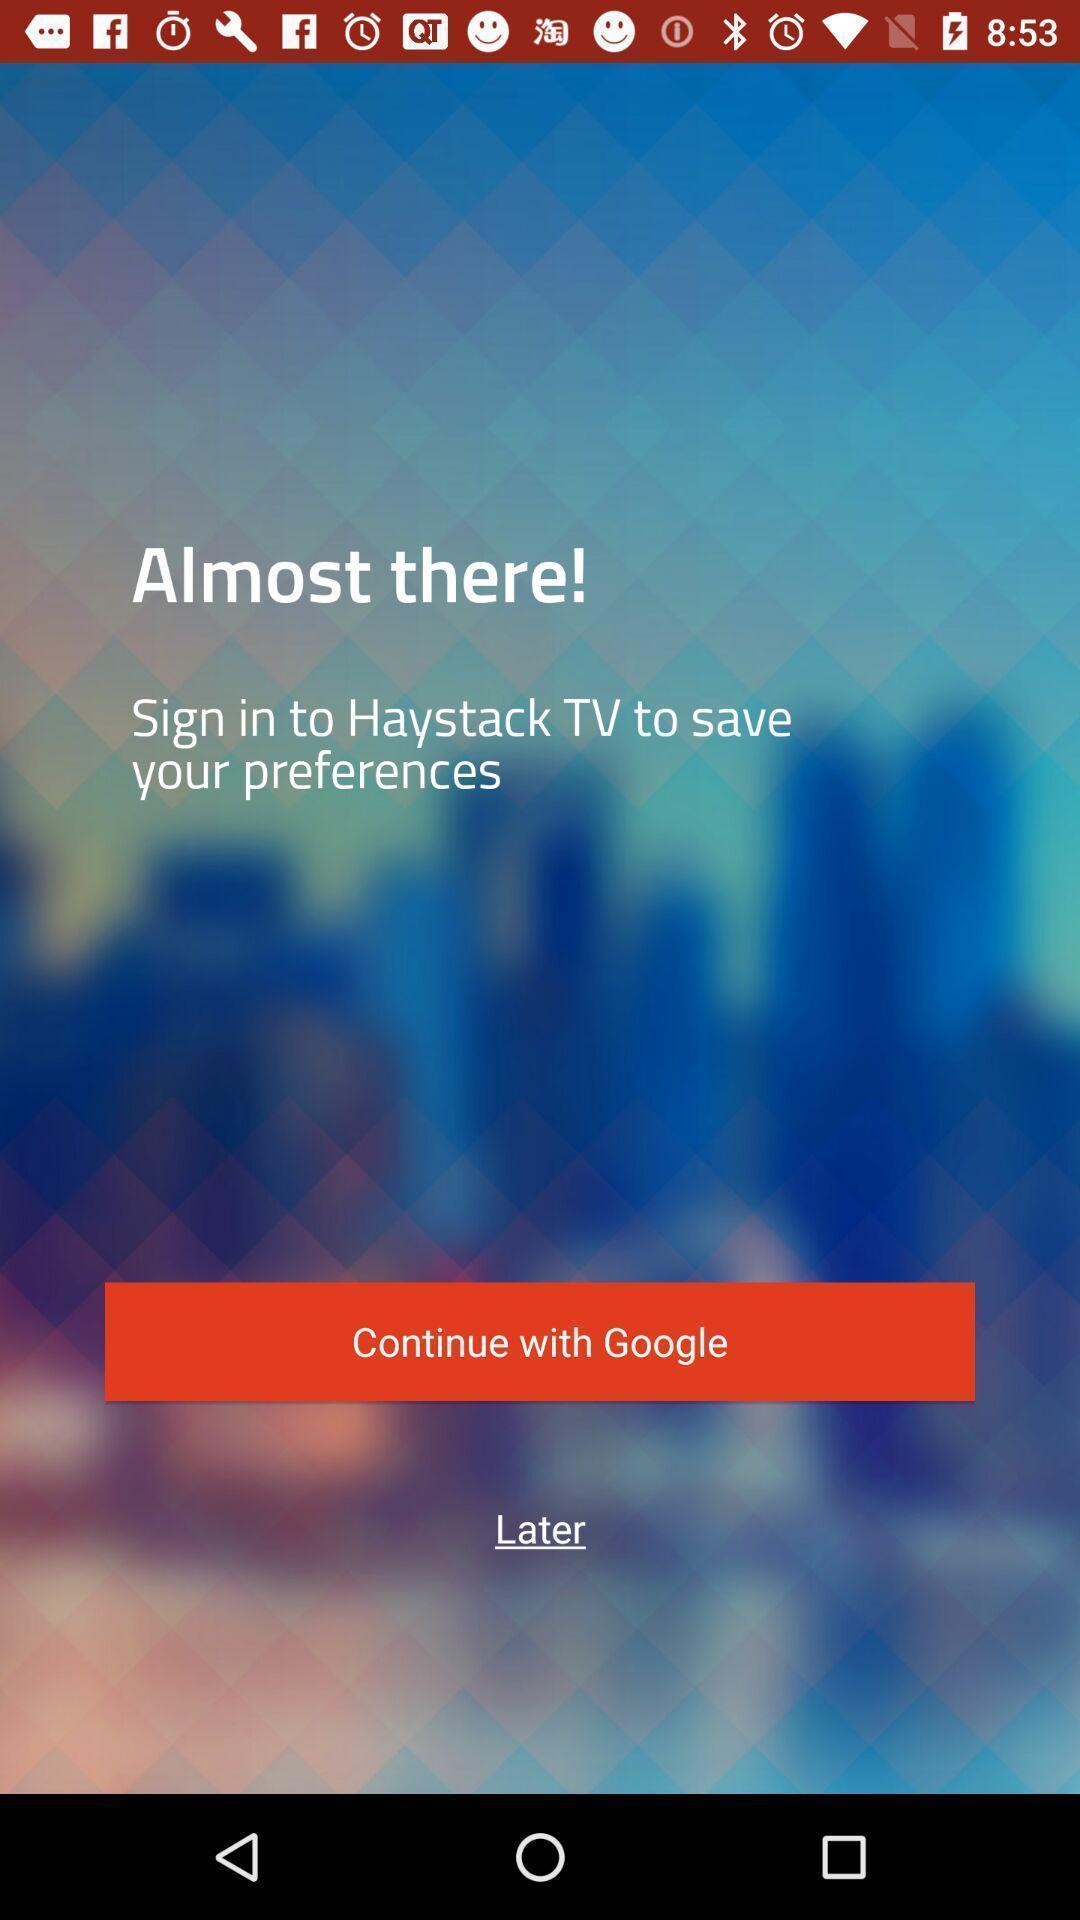Explain the elements present in this screenshot. Welcome page for a news streaming app. 